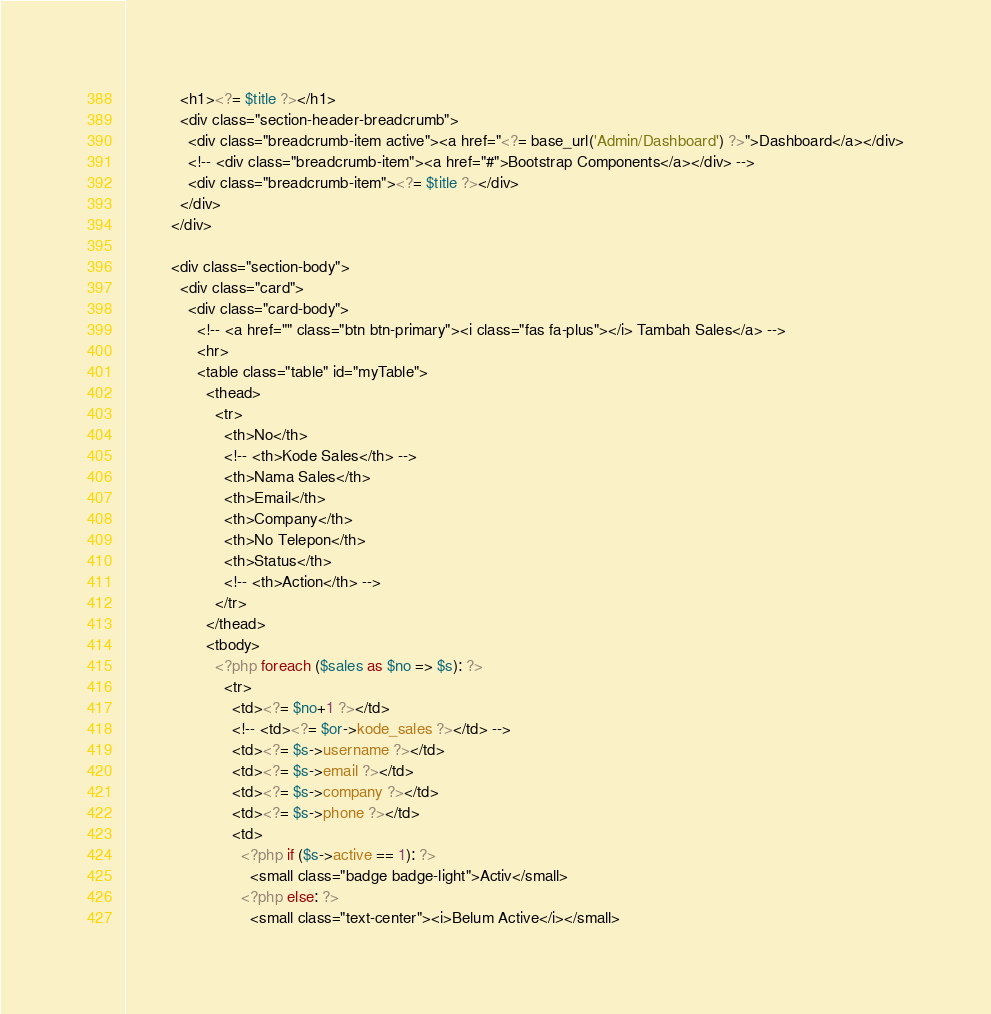Convert code to text. <code><loc_0><loc_0><loc_500><loc_500><_PHP_>            <h1><?= $title ?></h1>
            <div class="section-header-breadcrumb">
              <div class="breadcrumb-item active"><a href="<?= base_url('Admin/Dashboard') ?>">Dashboard</a></div>
              <!-- <div class="breadcrumb-item"><a href="#">Bootstrap Components</a></div> -->
              <div class="breadcrumb-item"><?= $title ?></div>
            </div>
          </div>

          <div class="section-body">
            <div class="card">
              <div class="card-body">
                <!-- <a href="" class="btn btn-primary"><i class="fas fa-plus"></i> Tambah Sales</a> -->
                <hr>
                <table class="table" id="myTable">
                  <thead>
                    <tr>
                      <th>No</th>
                      <!-- <th>Kode Sales</th> -->
                      <th>Nama Sales</th>
                      <th>Email</th>
                      <th>Company</th>
                      <th>No Telepon</th>
                      <th>Status</th>
                      <!-- <th>Action</th> -->
                    </tr>
                  </thead>        
                  <tbody>
                    <?php foreach ($sales as $no => $s): ?>
                      <tr>
                        <td><?= $no+1 ?></td>
                        <!-- <td><?= $or->kode_sales ?></td> -->
                        <td><?= $s->username ?></td>
                        <td><?= $s->email ?></td>
                        <td><?= $s->company ?></td>
                        <td><?= $s->phone ?></td>
                        <td>
                          <?php if ($s->active == 1): ?>
                            <small class="badge badge-light">Activ</small>
                          <?php else: ?>
                            <small class="text-center"><i>Belum Active</i></small></code> 